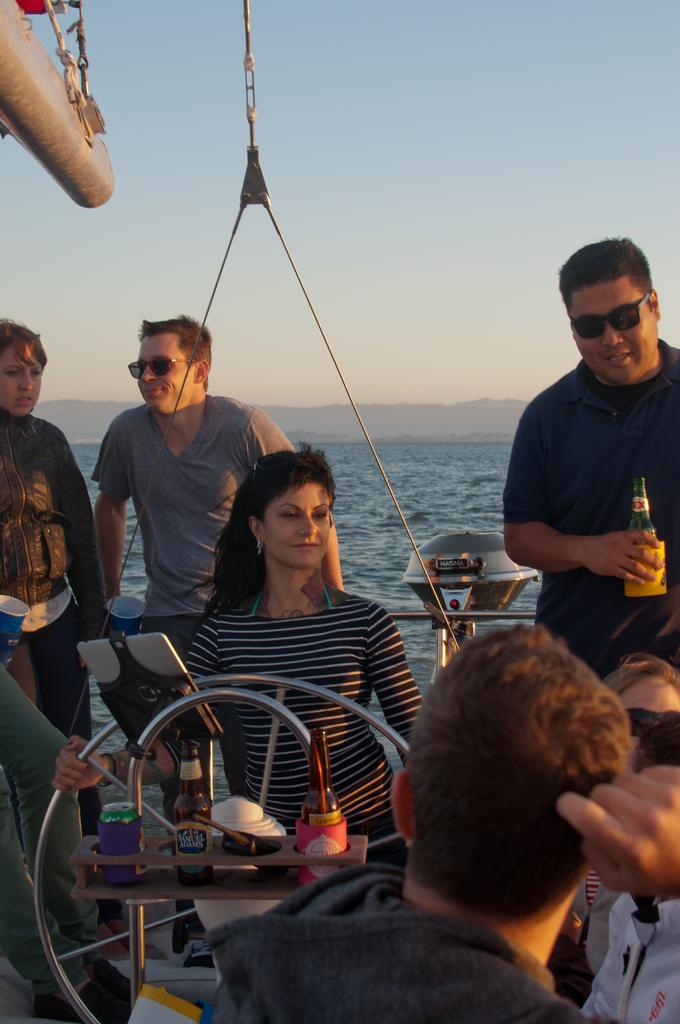How many people are in the image? There is a group of people in the image. What objects can be seen besides the people? There are bottles and a tin visible in the image. What is the woman in the image doing? The woman is holding a steering wheel with her hand. What can be seen in the background of the image? There is water and the sky visible in the background of the image. How many crates are being carried by the brothers in the image? There are no brothers or crates present in the image. What type of lock is securing the tin in the image? There is no lock present in the image; the tin is simply visible. 